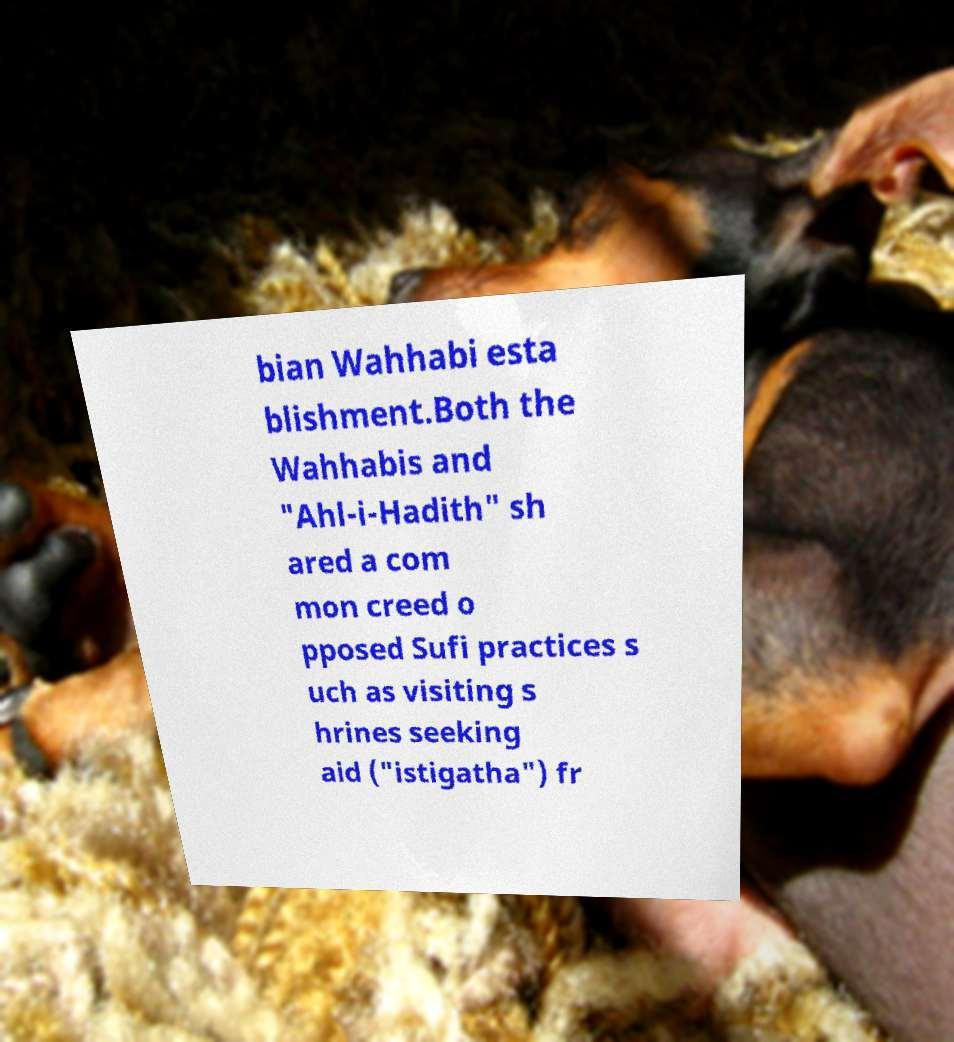Can you accurately transcribe the text from the provided image for me? bian Wahhabi esta blishment.Both the Wahhabis and "Ahl-i-Hadith" sh ared a com mon creed o pposed Sufi practices s uch as visiting s hrines seeking aid ("istigatha") fr 